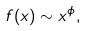<formula> <loc_0><loc_0><loc_500><loc_500>f ( x ) \sim x ^ { \phi } ,</formula> 